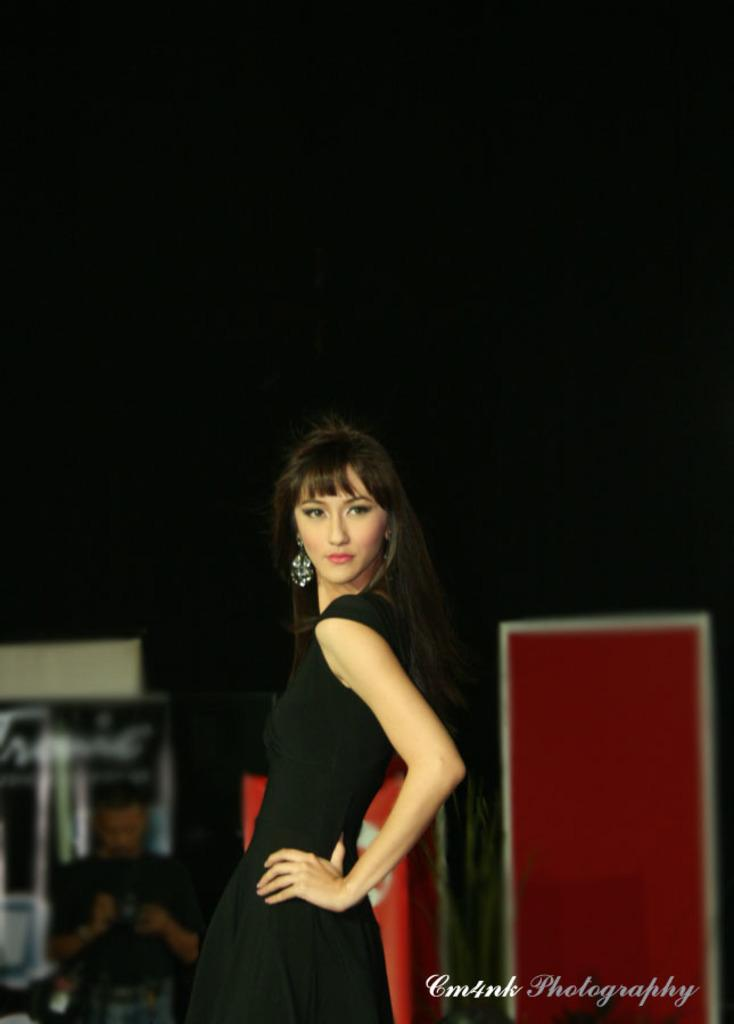What is the main subject of the image? There is a woman standing and posing in the image. Can you describe any additional features or elements in the image? Yes, there is a watermark in the image. Are there any other people present in the image? Yes, there is a person holding an object and standing in the background of the image. What type of marble is the woman standing on in the image? There is no marble visible in the image; it does not mention the surface the woman is standing on. How does the rat contribute to the knowledge depicted in the image? There is no rat present in the image, so it cannot contribute to any knowledge depicted. 